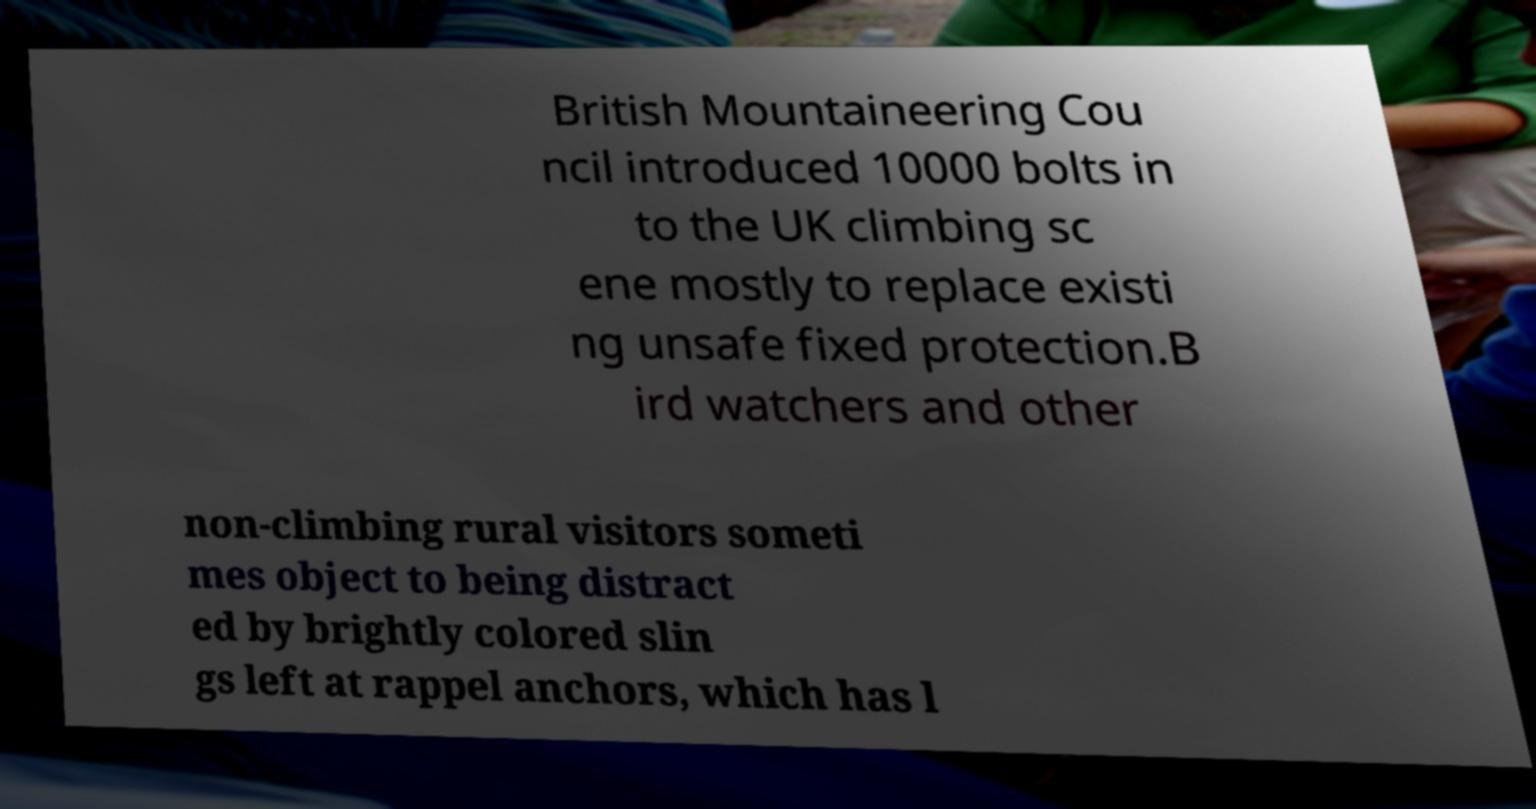What messages or text are displayed in this image? I need them in a readable, typed format. British Mountaineering Cou ncil introduced 10000 bolts in to the UK climbing sc ene mostly to replace existi ng unsafe fixed protection.B ird watchers and other non-climbing rural visitors someti mes object to being distract ed by brightly colored slin gs left at rappel anchors, which has l 